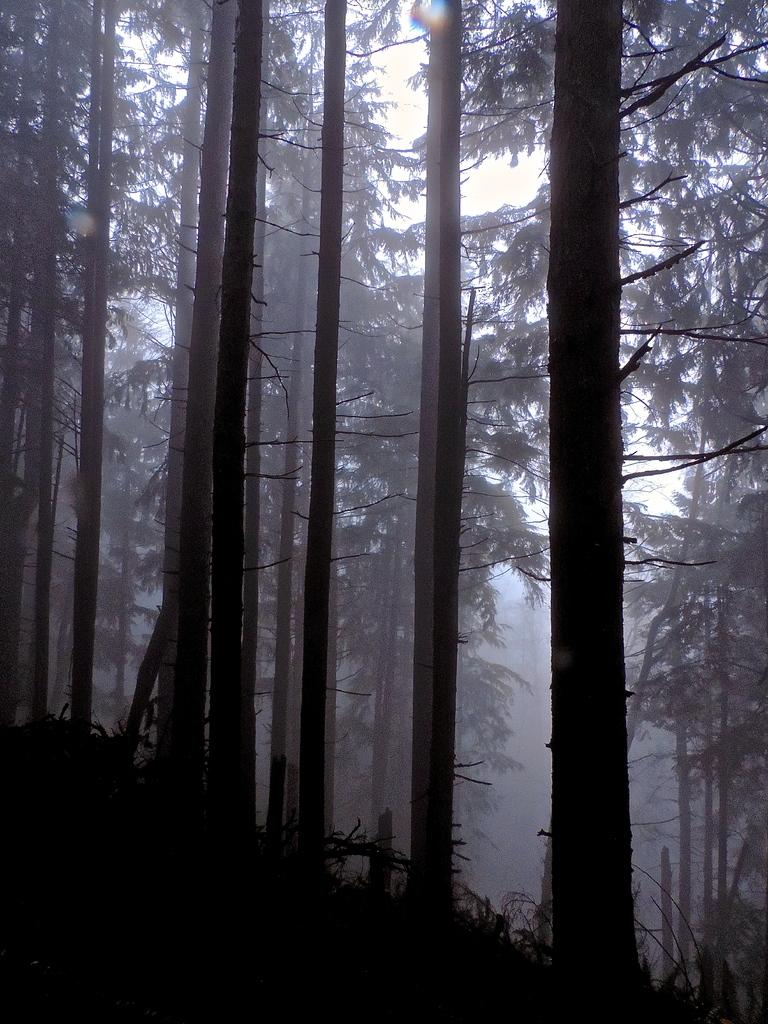What type of vegetation is present at the bottom of the image? There are trees and plants on the ground at the bottom of the image. What can be seen in the background of the image? There is smoke and the sky visible in the background of the image. How many spiders are crawling on the trees in the image? There are no spiders present in the image; it only features trees and plants. What type of noise can be heard coming from the smoke in the image? There is no sound or noise present in the image, as it is a static visual representation. 